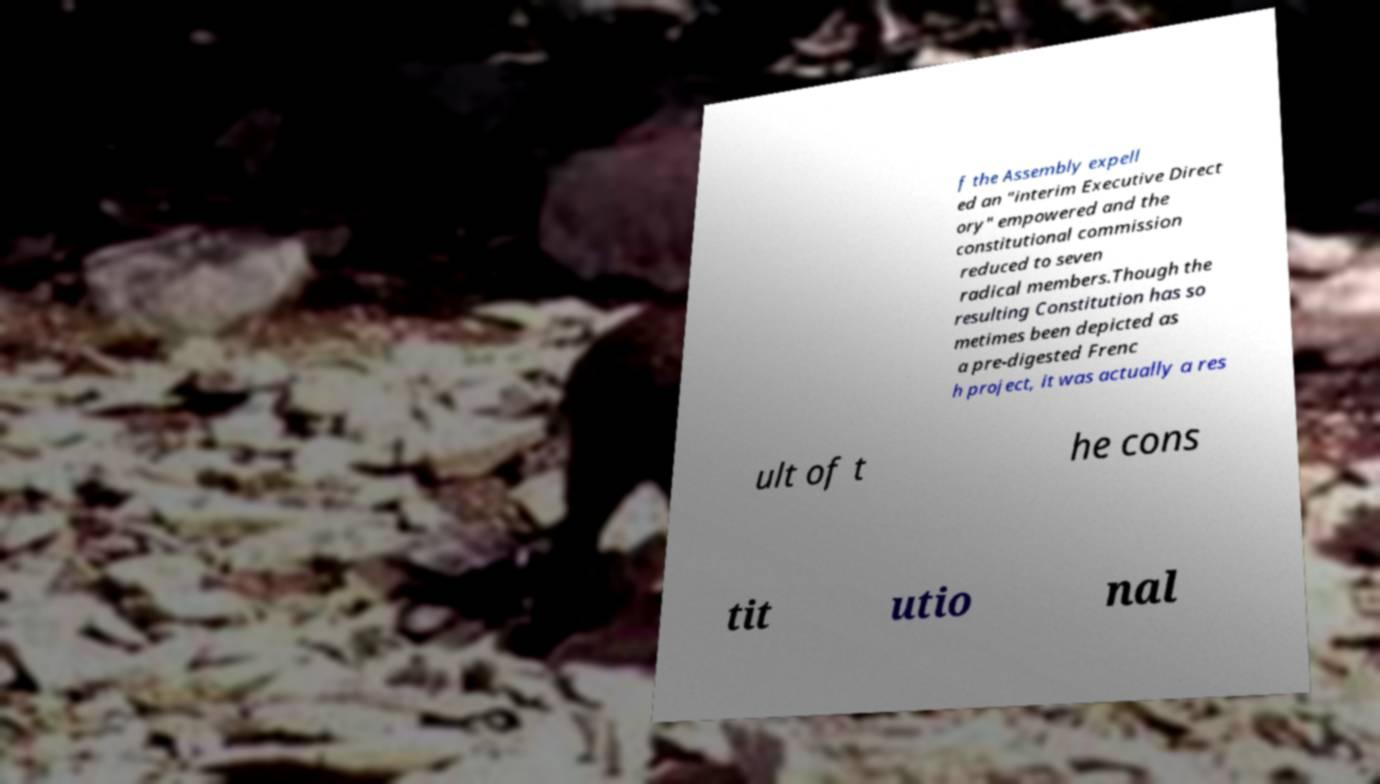Please read and relay the text visible in this image. What does it say? f the Assembly expell ed an "interim Executive Direct ory" empowered and the constitutional commission reduced to seven radical members.Though the resulting Constitution has so metimes been depicted as a pre-digested Frenc h project, it was actually a res ult of t he cons tit utio nal 